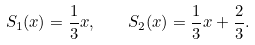<formula> <loc_0><loc_0><loc_500><loc_500>S _ { 1 } ( x ) = \frac { 1 } { 3 } x , \quad S _ { 2 } ( x ) = \frac { 1 } { 3 } x + \frac { 2 } { 3 } .</formula> 